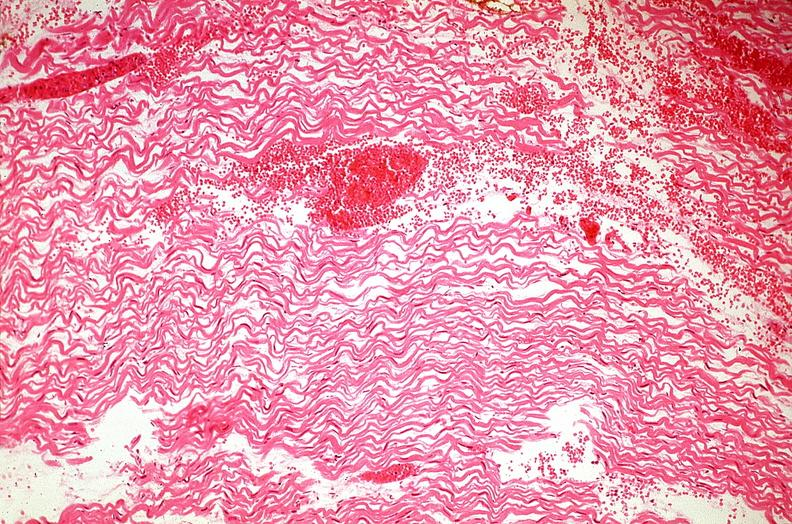s subdiaphragmatic abscess present?
Answer the question using a single word or phrase. No 